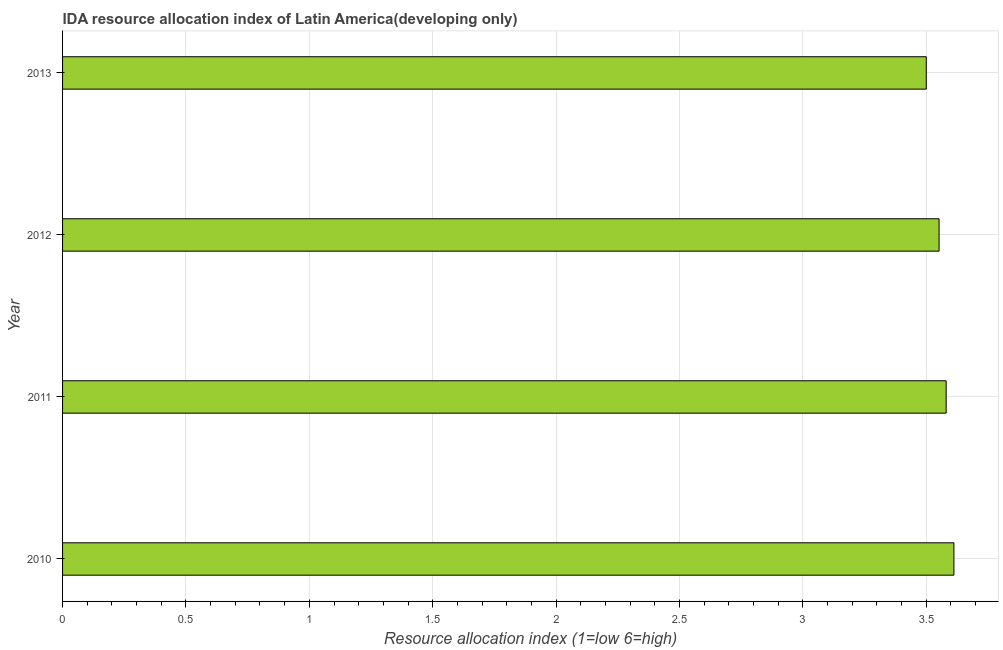What is the title of the graph?
Ensure brevity in your answer.  IDA resource allocation index of Latin America(developing only). What is the label or title of the X-axis?
Offer a very short reply. Resource allocation index (1=low 6=high). Across all years, what is the maximum ida resource allocation index?
Make the answer very short. 3.61. In which year was the ida resource allocation index maximum?
Your answer should be compact. 2010. What is the sum of the ida resource allocation index?
Provide a short and direct response. 14.24. What is the difference between the ida resource allocation index in 2011 and 2013?
Make the answer very short. 0.08. What is the average ida resource allocation index per year?
Provide a short and direct response. 3.56. What is the median ida resource allocation index?
Offer a terse response. 3.57. What is the ratio of the ida resource allocation index in 2012 to that in 2013?
Keep it short and to the point. 1.01. Is the ida resource allocation index in 2010 less than that in 2012?
Give a very brief answer. No. Is the difference between the ida resource allocation index in 2011 and 2012 greater than the difference between any two years?
Offer a very short reply. No. What is the difference between the highest and the second highest ida resource allocation index?
Offer a very short reply. 0.03. Is the sum of the ida resource allocation index in 2011 and 2012 greater than the maximum ida resource allocation index across all years?
Provide a short and direct response. Yes. What is the difference between the highest and the lowest ida resource allocation index?
Keep it short and to the point. 0.11. In how many years, is the ida resource allocation index greater than the average ida resource allocation index taken over all years?
Your answer should be compact. 2. How many bars are there?
Keep it short and to the point. 4. What is the difference between two consecutive major ticks on the X-axis?
Offer a terse response. 0.5. What is the Resource allocation index (1=low 6=high) in 2010?
Offer a terse response. 3.61. What is the Resource allocation index (1=low 6=high) in 2011?
Your response must be concise. 3.58. What is the Resource allocation index (1=low 6=high) in 2012?
Provide a succinct answer. 3.55. What is the Resource allocation index (1=low 6=high) of 2013?
Your response must be concise. 3.5. What is the difference between the Resource allocation index (1=low 6=high) in 2010 and 2011?
Offer a very short reply. 0.03. What is the difference between the Resource allocation index (1=low 6=high) in 2010 and 2012?
Offer a very short reply. 0.06. What is the difference between the Resource allocation index (1=low 6=high) in 2010 and 2013?
Keep it short and to the point. 0.11. What is the difference between the Resource allocation index (1=low 6=high) in 2011 and 2012?
Your answer should be compact. 0.03. What is the difference between the Resource allocation index (1=low 6=high) in 2011 and 2013?
Keep it short and to the point. 0.08. What is the difference between the Resource allocation index (1=low 6=high) in 2012 and 2013?
Make the answer very short. 0.05. What is the ratio of the Resource allocation index (1=low 6=high) in 2010 to that in 2012?
Offer a terse response. 1.02. What is the ratio of the Resource allocation index (1=low 6=high) in 2010 to that in 2013?
Offer a very short reply. 1.03. What is the ratio of the Resource allocation index (1=low 6=high) in 2011 to that in 2012?
Provide a succinct answer. 1.01. What is the ratio of the Resource allocation index (1=low 6=high) in 2011 to that in 2013?
Your answer should be compact. 1.02. What is the ratio of the Resource allocation index (1=low 6=high) in 2012 to that in 2013?
Ensure brevity in your answer.  1.01. 